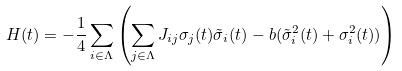<formula> <loc_0><loc_0><loc_500><loc_500>H ( t ) = - \frac { 1 } { 4 } \sum _ { i \in \Lambda } \left ( \sum _ { j \in \Lambda } J _ { i j } \sigma _ { j } ( t ) \tilde { \sigma } _ { i } ( t ) - b ( \tilde { \sigma } _ { i } ^ { 2 } ( t ) + \sigma _ { i } ^ { 2 } ( t ) ) \right )</formula> 